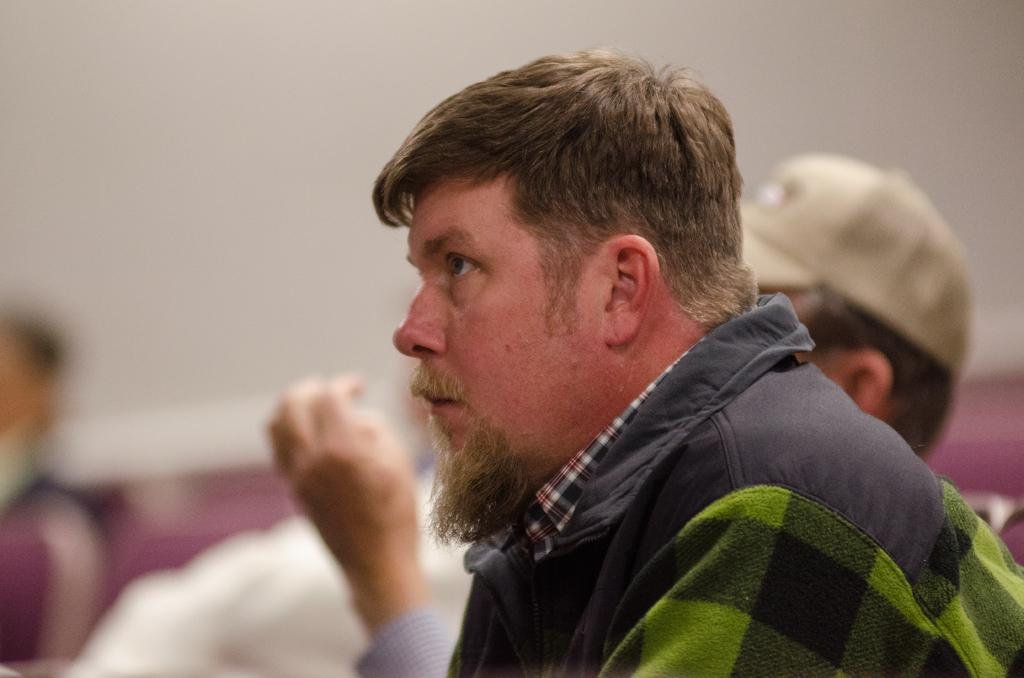Who is present in the image? There is a man in the image. What is the man wearing? The man is wearing a jacket. Are there any other individuals in the image? Yes, there are other people in the image. Can you describe the background of the image? The background of the image is slightly blurry. What type of sea creature can be seen in the image? There is no sea creature present in the image. What is the man using to cut the flag in the image? There is no flag or scissors present in the image. 